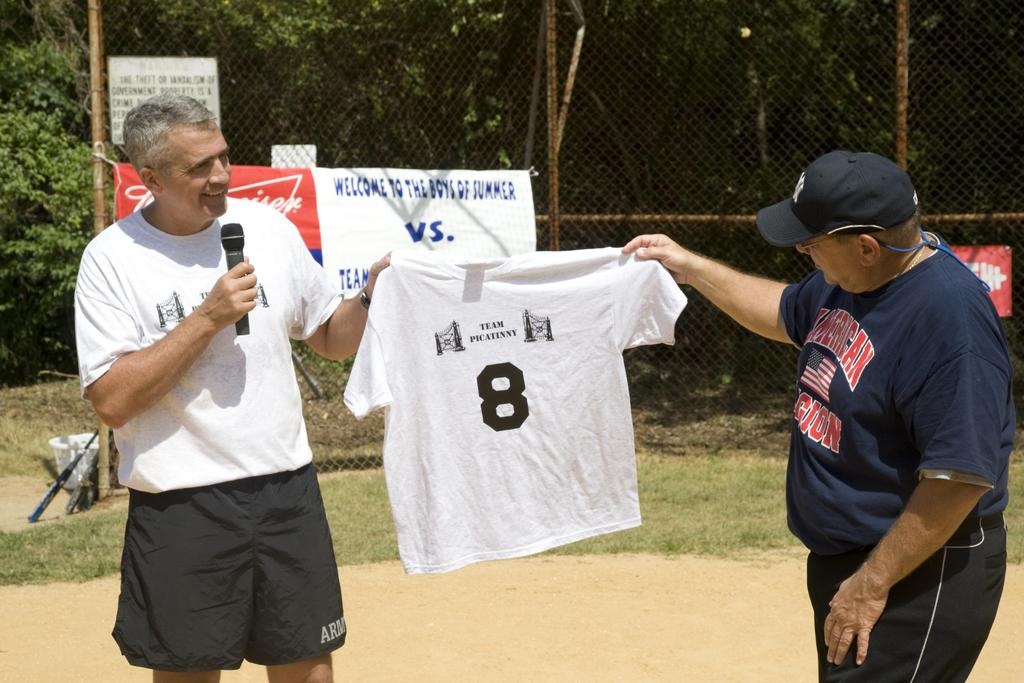<image>
Summarize the visual content of the image. A man in an American Legion shirt holds up a shirt with another man. 